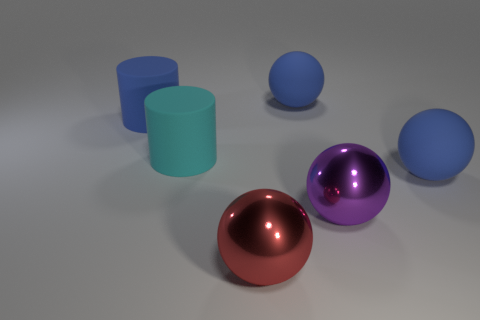Is there a thing to the left of the large rubber cylinder to the right of the big blue matte thing that is on the left side of the large red object?
Give a very brief answer. Yes. The other matte cylinder that is the same size as the blue cylinder is what color?
Your response must be concise. Cyan. There is a large rubber object in front of the cyan matte thing; is it the same shape as the big cyan thing?
Give a very brief answer. No. What is the color of the metal object on the left side of the blue rubber sphere that is behind the big blue matte sphere on the right side of the big purple shiny thing?
Give a very brief answer. Red. Is there a sphere?
Give a very brief answer. Yes. What number of other objects are the same size as the purple sphere?
Give a very brief answer. 5. How many objects are big cyan rubber balls or blue things?
Keep it short and to the point. 3. Is the large purple thing made of the same material as the big sphere in front of the big purple shiny thing?
Your response must be concise. Yes. What is the shape of the cyan rubber thing that is in front of the big blue matte thing that is to the left of the big red ball?
Your response must be concise. Cylinder. The object that is both in front of the big cyan matte object and behind the large purple sphere has what shape?
Your answer should be compact. Sphere. 